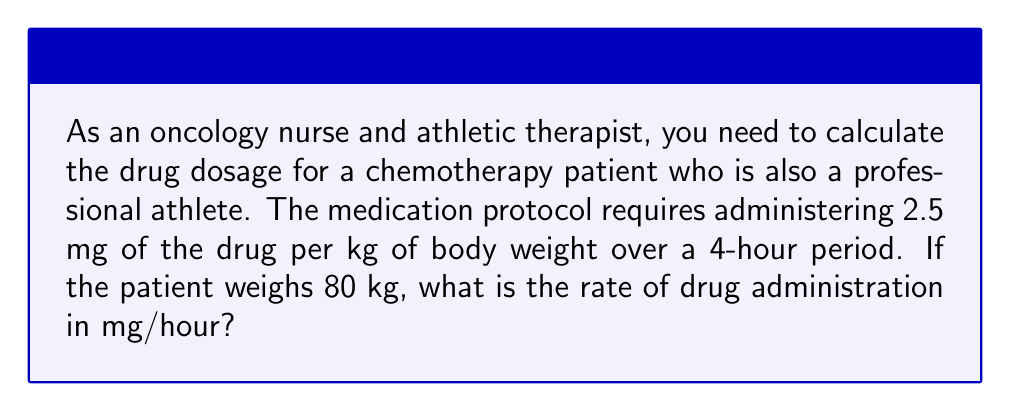Solve this math problem. To solve this problem, let's break it down into steps:

1. Calculate the total drug dosage:
   $$\text{Total dosage} = \text{Dosage per kg} \times \text{Patient weight}$$
   $$\text{Total dosage} = 2.5 \text{ mg/kg} \times 80 \text{ kg} = 200 \text{ mg}$$

2. Determine the time period for administration:
   The drug is to be administered over a 4-hour period.

3. Calculate the rate of drug administration:
   $$\text{Rate} = \frac{\text{Total dosage}}{\text{Time period}}$$
   $$\text{Rate} = \frac{200 \text{ mg}}{4 \text{ hours}}$$
   $$\text{Rate} = 50 \text{ mg/hour}$$

Therefore, the drug should be administered at a rate of 50 mg per hour.
Answer: $50 \text{ mg/hour}$ 